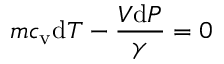Convert formula to latex. <formula><loc_0><loc_0><loc_500><loc_500>m c _ { v } d T - { \frac { V d P } { \gamma } } = 0</formula> 